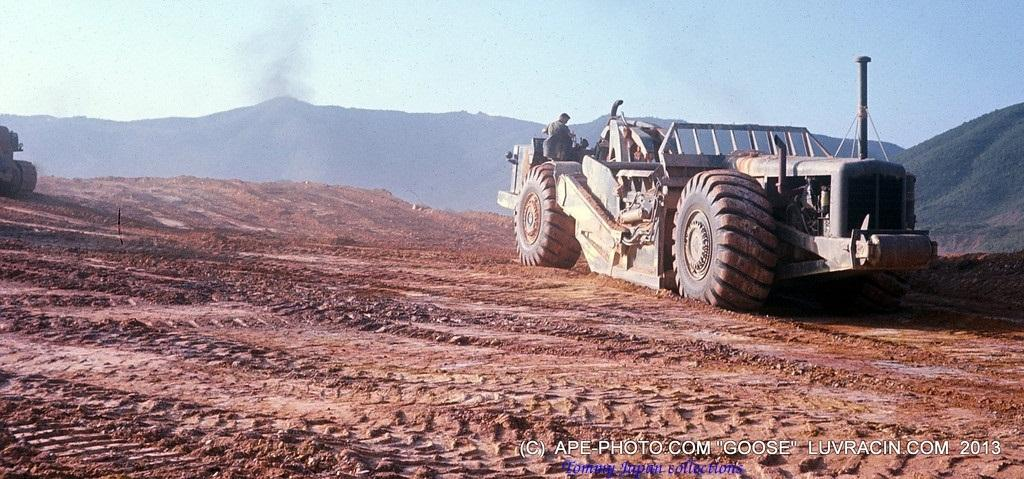What can be seen on the ground in the image? There are vehicles on the ground in the image. What type of natural landscape is visible in the background of the image? There are mountains visible in the background of the image. What else can be seen in the background of the image? The sky is visible in the background of the image. How does the print on the vehicles connect to the mountains in the image? There is no mention of any print on the vehicles, and the vehicles and mountains are separate subjects in the image. What type of care is required for the mountains in the image? The mountains in the image are a natural landscape and do not require any care. 